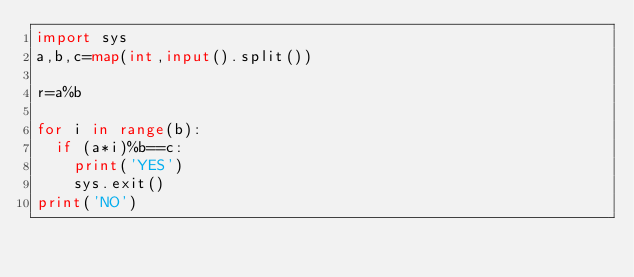<code> <loc_0><loc_0><loc_500><loc_500><_Python_>import sys
a,b,c=map(int,input().split())

r=a%b

for i in range(b):
  if (a*i)%b==c:
    print('YES')
    sys.exit()
print('NO')</code> 